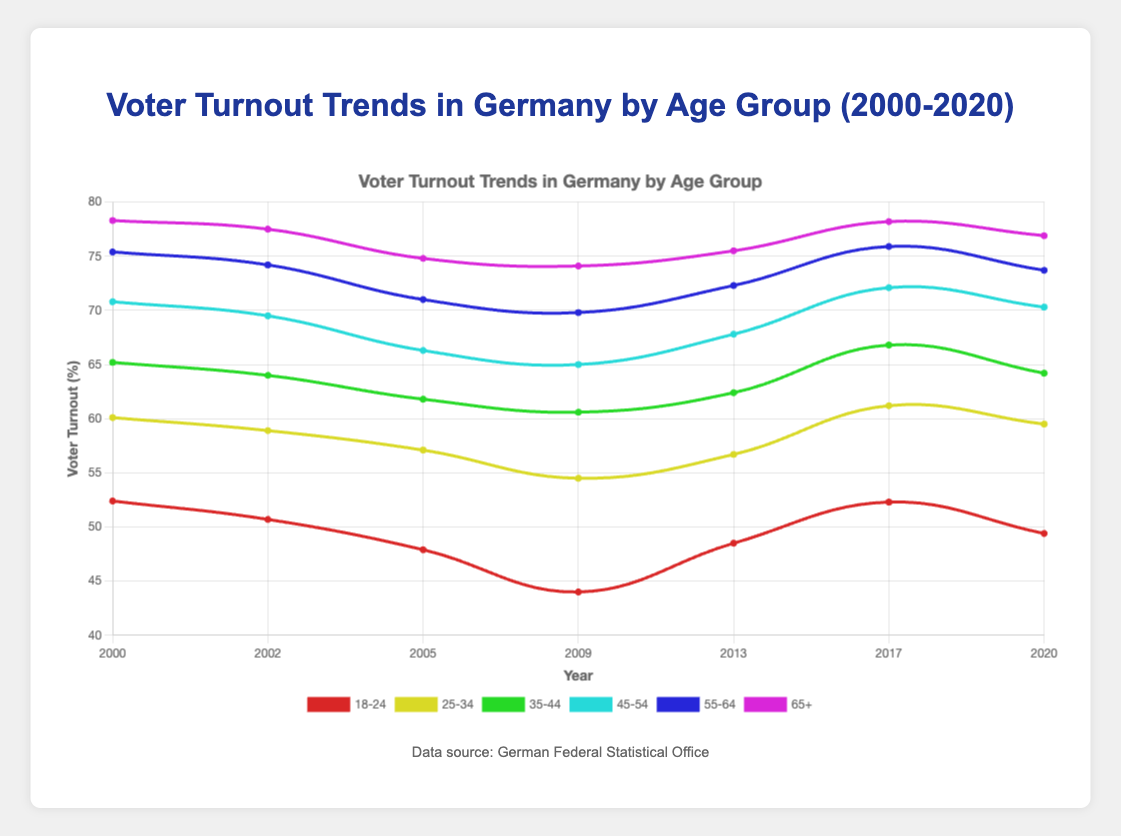Which age group had the highest voter turnout in 2020? To identify the age group with the highest voter turnout in 2020, look at the plot for the year 2020 and locate the curve that reaches the highest point on the y-axis. The curve representing the 65+ age group is the highest.
Answer: 65+ How did the voter turnout for the 18-24 age group change from 2000 to 2020? Examine the curve for the 18-24 age group in 2000 and 2020. In 2000, the turnout was 52.4%, and in 2020, it was 49.4%. The voter turnout decreased by 3%.
Answer: Decreased Which age group experienced the most significant decrease in voter turnout from 2000 to 2009? To determine the age group with the most significant decrease, compare the changes in voter turnout for each age group between 2000 and 2009. The 18-24 age group decreased from 52.4% to 44%, a decrease of 8.4%. No other age group had a larger decrease.
Answer: 18-24 What is the average voter turnout for the 25-34 age group across all years? To calculate the average, sum the voter turnout percentages for the 25-34 age group across all the years and divide by the number of years: (60.1 + 58.9 + 57.1 + 54.5 + 56.7 + 61.2 + 59.5) / 7. This results in an average of approximately 58.3%.
Answer: 58.3% For which year did the 45-54 age group have the highest voter turnout? Look at the points on the plot representing the voter turnout for the 45-54 age group over the years. The highest point for this group is in 2017, where the turnout is 72.1%.
Answer: 2017 Compare the trends for the 35-44 and 55-64 age groups. Which group has shown a relatively steadier trend over the years? Examine both curves for the 35-44 and 55-64 age groups from 2000 to 2020. The 55-64 age group shows a more consistent gradual trend, while the 35-44 age group has more fluctuations, indicating the 55-64 group has a steadier trend.
Answer: 55-64 What is the difference in voter turnout between the 65+ and 18-24 age groups in 2009? Check the turnout for both age groups in 2009. The 65+ group had 74.1%, and the 18-24 group had 44%. The difference is 74.1% - 44% = 30.1%.
Answer: 30.1% Which age group shows the greatest increase in voter turnout from 2009 to 2017? Compare the changes for each age group between 2009 and 2017. The 18-24 age group increased from 44% to 52.3%, an increase of 8.3%, which is the greatest increment among all age groups.
Answer: 18-24 What is the trend observed in voter turnout for the 35-44 age group from 2000 to 2013? Inspect the plot for the 35-44 age group from 2000 to 2013. Turnout initially increased from 65.2% to 62.4%, then dropped to 60.6% in 2009 before rising again to 62.4% in 2013, showing an overall slightly declining yet oscillating trend.
Answer: Slightly declining, oscillating How does voter turnout in 2017 for the 25-34 age group compare to the turnout in 2005 for the same group? Refer to the turnout values for the 25-34 age group in 2017 and 2005. In 2017, the turnout was 61.2%, while in 2005, it was 57.1%. Comparing these values, the turnout in 2017 is higher.
Answer: Higher 